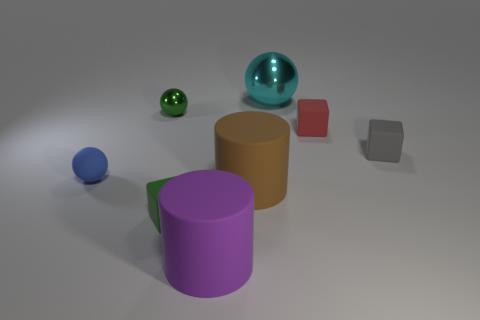Is the number of balls behind the big cyan ball less than the number of metal cylinders?
Offer a very short reply. No. Is the number of purple matte cylinders that are behind the big brown object greater than the number of tiny red rubber blocks that are to the right of the tiny gray rubber block?
Ensure brevity in your answer.  No. Is there anything else that has the same color as the large metallic sphere?
Offer a terse response. No. What is the green thing behind the gray rubber block made of?
Make the answer very short. Metal. Do the green cube and the cyan object have the same size?
Give a very brief answer. No. How many other things are the same size as the green metal ball?
Your response must be concise. 4. Is the tiny shiny sphere the same color as the large metal ball?
Keep it short and to the point. No. There is a metal thing that is behind the green object that is behind the small red cube behind the matte ball; what is its shape?
Make the answer very short. Sphere. How many things are either balls left of the brown thing or tiny matte objects that are on the right side of the purple matte cylinder?
Provide a succinct answer. 4. What is the size of the green object that is behind the tiny green object that is in front of the small metallic thing?
Keep it short and to the point. Small. 